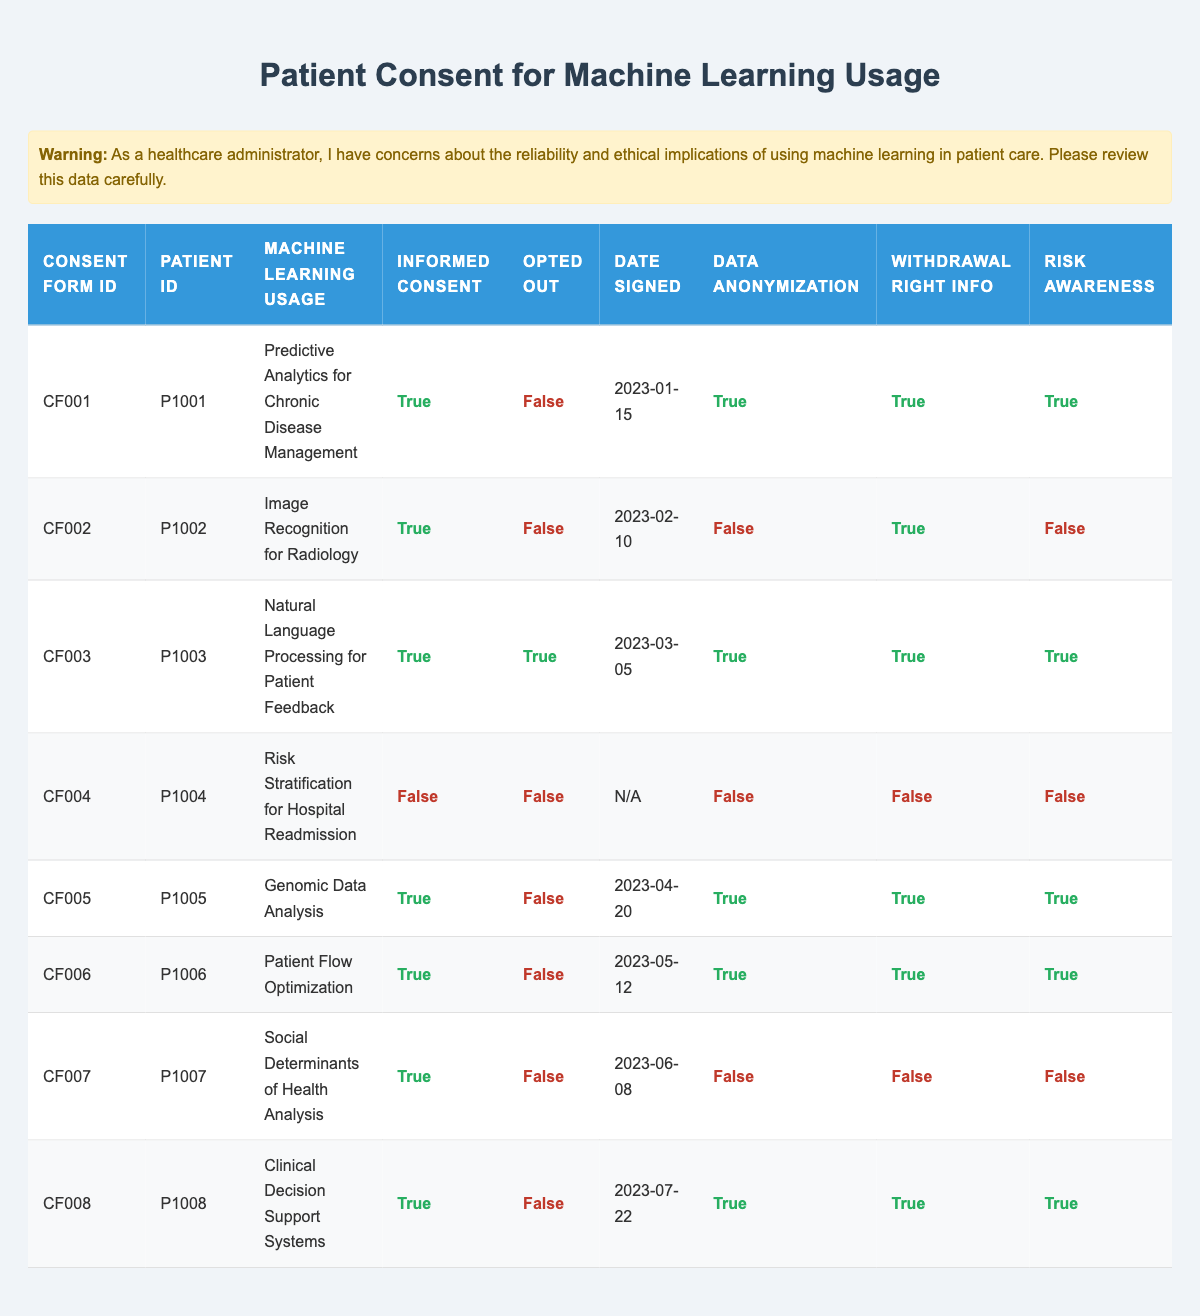What is the Machine Learning Usage for Patient ID P1003? Referring to the table, Patient ID P1003 is associated with the Machine Learning Usage "Natural Language Processing for Patient Feedback."
Answer: Natural Language Processing for Patient Feedback How many patients signed consent forms without being informed? Looking at the table, Patient ID P1004 is marked as "false" for Informed Consent and has a Consent Form ID of CF004. Therefore, only 1 patient signed a consent form without being informed.
Answer: 1 What is the total number of patients who opted out of using machine learning? In the table, Patient ID P1003 opted out of using machine learning. Therefore, only 1 patient opted out.
Answer: 1 Did Patient ID P1008 receive information about their right to withdraw? In the table, it shows that Patient ID P1008 has "true" under Withdrawal Right Info, meaning they did receive information about their right to withdraw.
Answer: Yes Which patient has the earliest date signed on their consent form? Comparing the dates signed in the table, P1001 signed on 2023-01-15, which is the earliest date, while others are later.
Answer: P1001 How many patients have both data anonymization and risk awareness? Looking through the table, Patients P1001, P1005, P1006, P1008 have both Data Anonymization and Risk Awareness marked as true, giving us a total of 4 patients.
Answer: 4 Is there a patient who opted out but did not have informed consent? Looking at Patient ID P1004, they did not have informed consent, but they did not opt out either. So, there is no patient who fits this criterion.
Answer: No Which Machine Learning Usage has the highest number of issues with data anonymization? In the table, both P1002, P1004, and P1007 show issues with data anonymization. P1004 has the most issues as it also lacks informed consent and other rights information.
Answer: Risk Stratification for Hospital Readmission What percentage of patients signed their consent forms with an informed consent? There are 8 patients total where 6 of them indicated informed consent. Therefore, the percentage is (6/8) * 100 = 75%.
Answer: 75% 